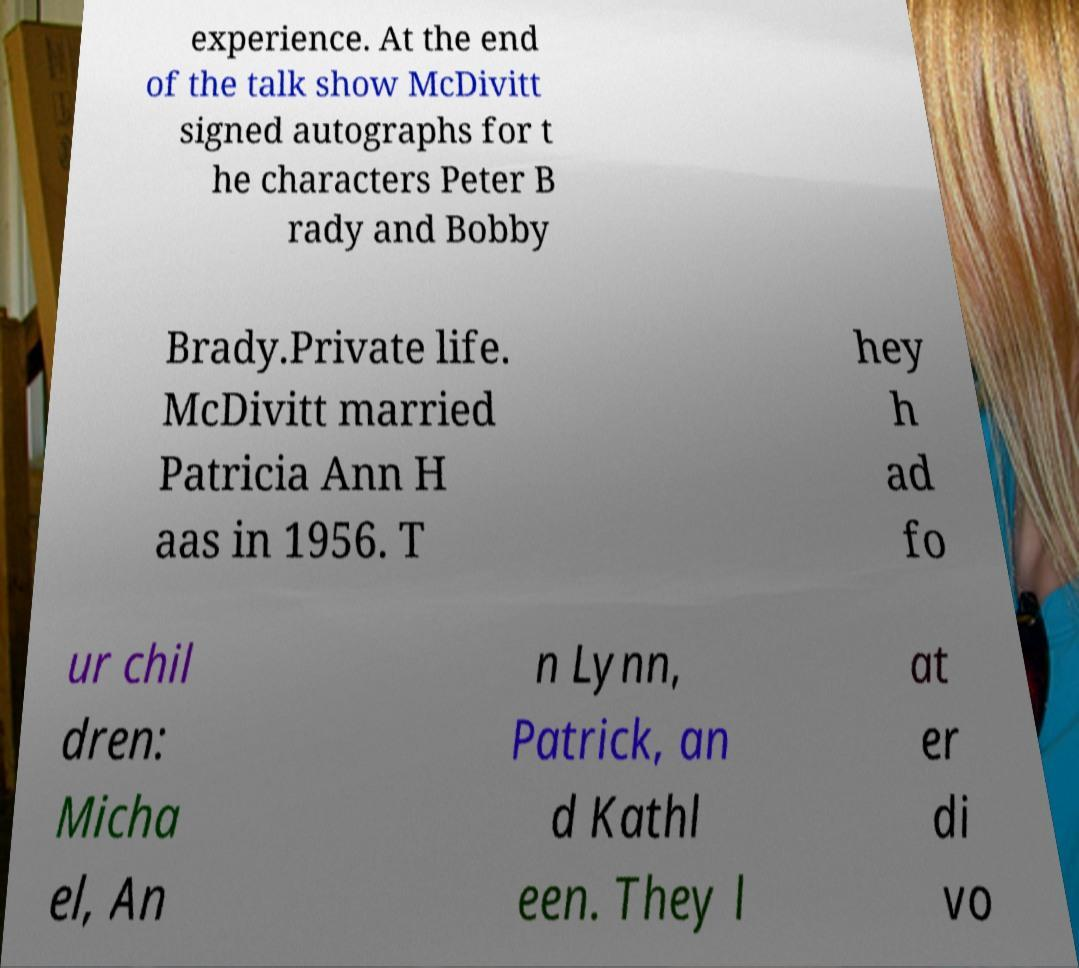For documentation purposes, I need the text within this image transcribed. Could you provide that? experience. At the end of the talk show McDivitt signed autographs for t he characters Peter B rady and Bobby Brady.Private life. McDivitt married Patricia Ann H aas in 1956. T hey h ad fo ur chil dren: Micha el, An n Lynn, Patrick, an d Kathl een. They l at er di vo 